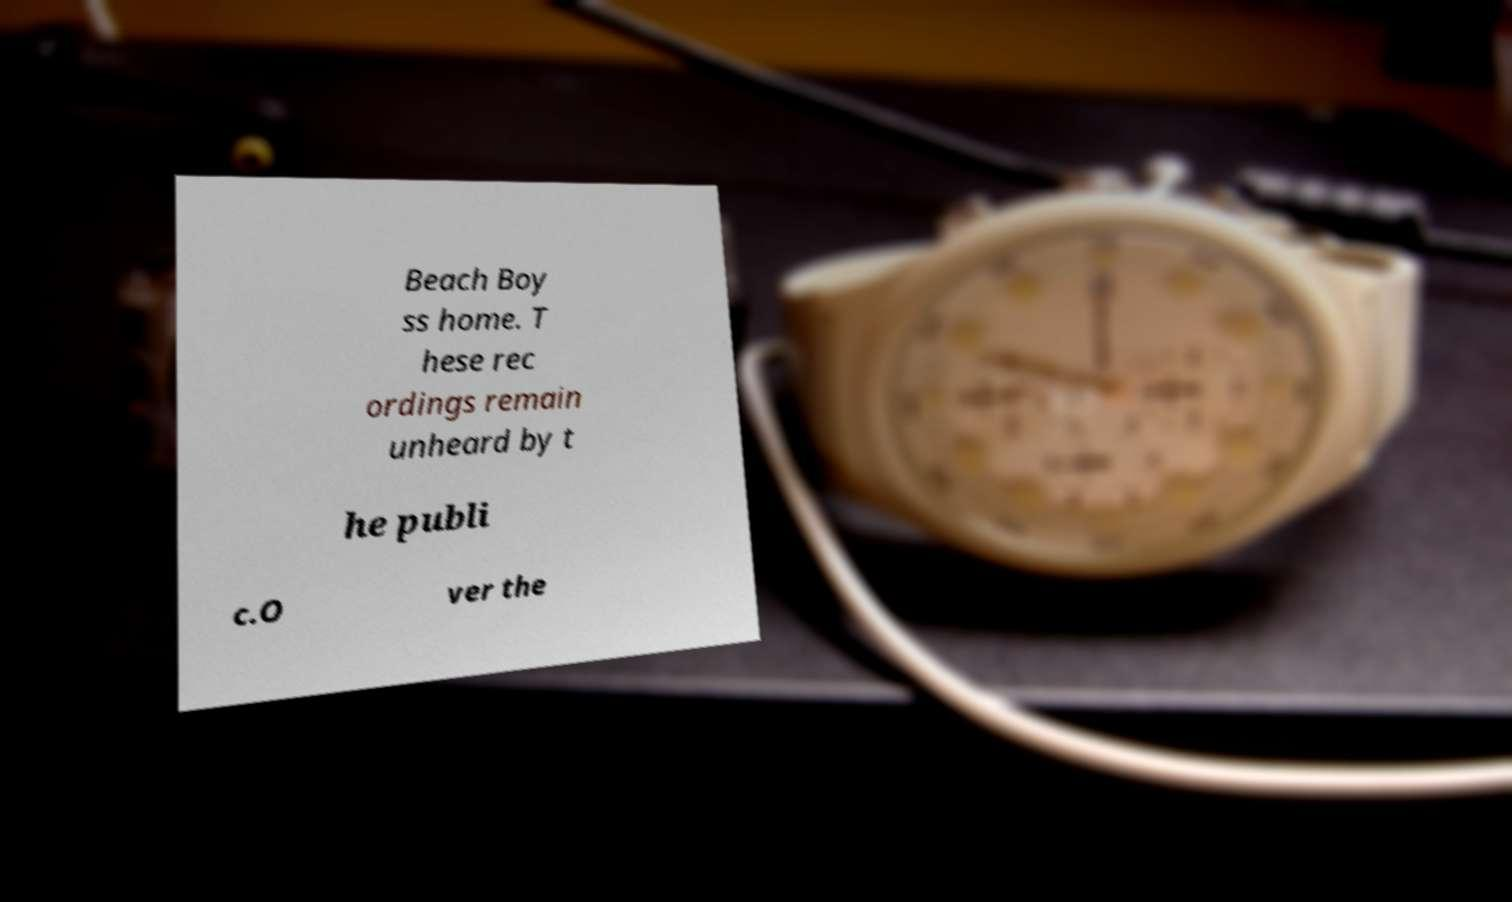Could you assist in decoding the text presented in this image and type it out clearly? Beach Boy ss home. T hese rec ordings remain unheard by t he publi c.O ver the 